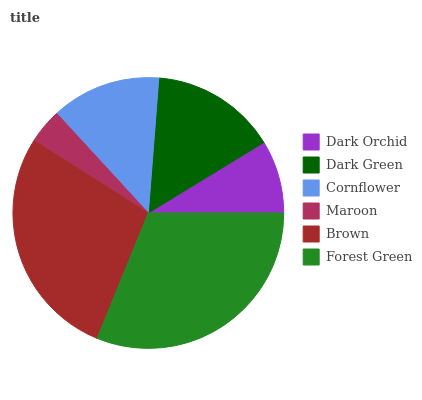Is Maroon the minimum?
Answer yes or no. Yes. Is Forest Green the maximum?
Answer yes or no. Yes. Is Dark Green the minimum?
Answer yes or no. No. Is Dark Green the maximum?
Answer yes or no. No. Is Dark Green greater than Dark Orchid?
Answer yes or no. Yes. Is Dark Orchid less than Dark Green?
Answer yes or no. Yes. Is Dark Orchid greater than Dark Green?
Answer yes or no. No. Is Dark Green less than Dark Orchid?
Answer yes or no. No. Is Dark Green the high median?
Answer yes or no. Yes. Is Cornflower the low median?
Answer yes or no. Yes. Is Cornflower the high median?
Answer yes or no. No. Is Dark Orchid the low median?
Answer yes or no. No. 